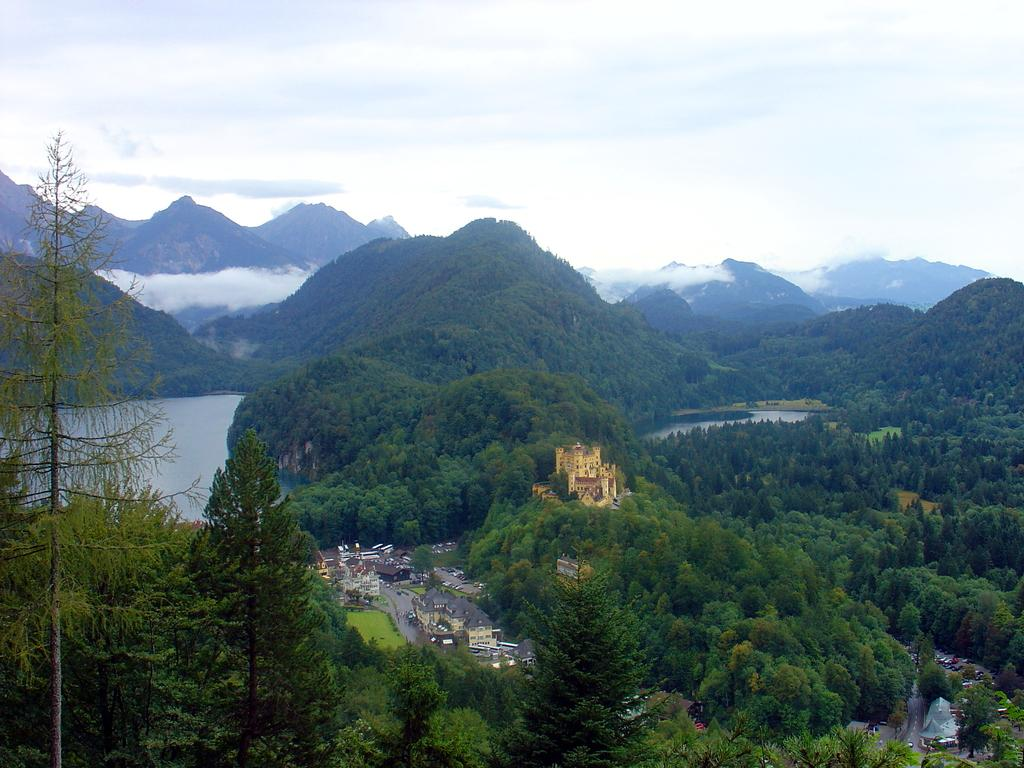What type of natural elements can be seen in the image? There are trees in the image. What type of man-made structures are present in the image? There are buildings in the image. What can be seen in the distance in the image? There are mountains in the background of the image. What else is visible in the background of the image? There is water visible in the background of the image. Can you tell me how many chickens are present in the image? There are no chickens present in the image. What example can be seen in the image that represents the harmony between nature and man-made structures? The image itself serves as an example of the harmony between nature and man-made structures, but there is no specific representative element mentioned in the provided facts. 